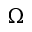Convert formula to latex. <formula><loc_0><loc_0><loc_500><loc_500>\Omega</formula> 